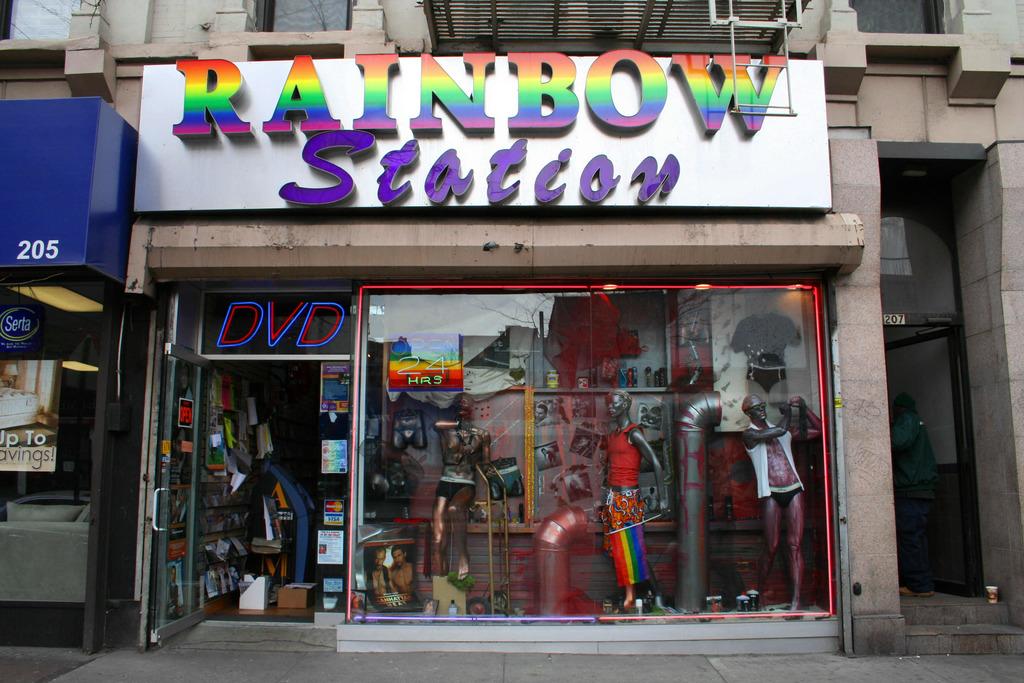What does it say above the doorway in 3 letters?
Give a very brief answer. Dvd. What kind of station?
Make the answer very short. Rainbow. 